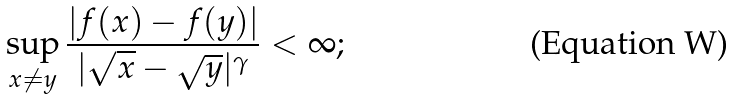Convert formula to latex. <formula><loc_0><loc_0><loc_500><loc_500>\sup _ { x \neq y } \frac { | f ( x ) - f ( y ) | } { | \sqrt { x } - \sqrt { y } | ^ { \gamma } } < \infty ;</formula> 